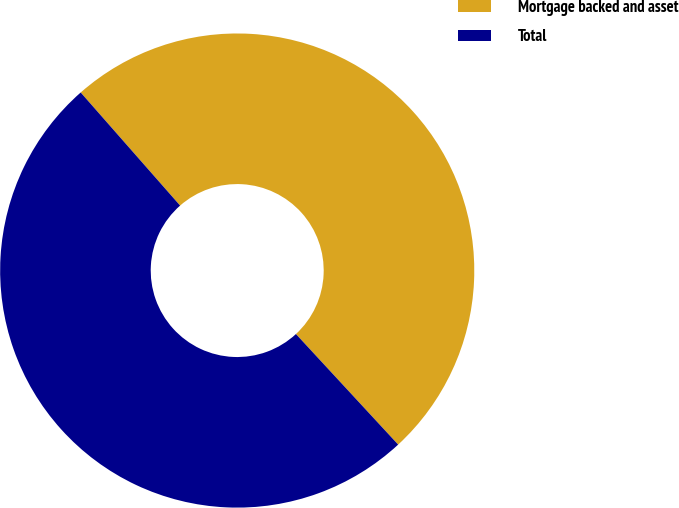Convert chart. <chart><loc_0><loc_0><loc_500><loc_500><pie_chart><fcel>Mortgage backed and asset<fcel>Total<nl><fcel>49.6%<fcel>50.4%<nl></chart> 